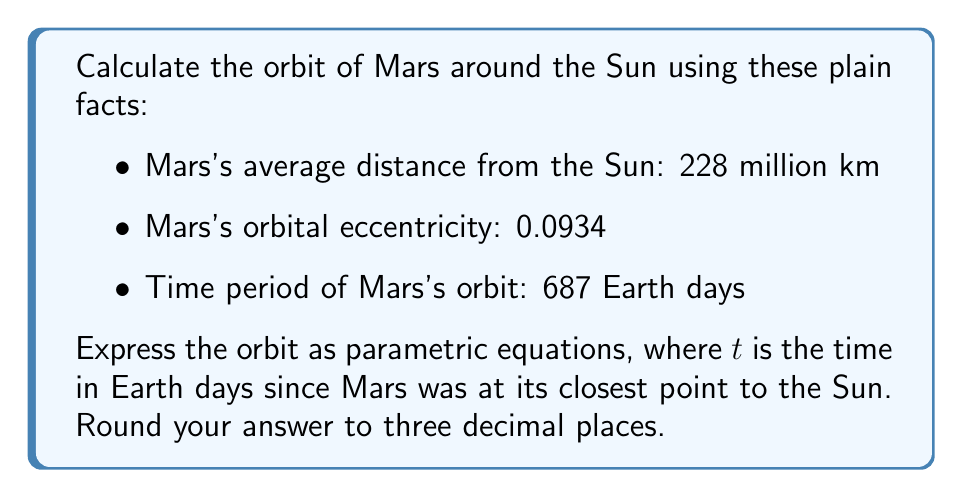Provide a solution to this math problem. Let's break this down step-by-step:

1) The orbit of a planet around the Sun is an ellipse. We can describe this using parametric equations:

   $x = a \cos(E)$
   $y = b \sin(E)$

   Where $a$ is the semi-major axis, $b$ is the semi-minor axis, and $E$ is the eccentric anomaly.

2) We're given the average distance (228 million km) which is the semi-major axis $a$.

3) The eccentricity $e$ is 0.0934. We can find $b$ using:

   $b = a\sqrt{1-e^2} = 228\sqrt{1-0.0934^2} = 226.986$ million km

4) To relate time $t$ to position, we need Kepler's equation:

   $M = E - e \sin(E)$

   Where $M$ is the mean anomaly: $M = \frac{2\pi t}{T}$, and $T$ is the orbital period (687 days).

5) We can't solve this equation directly, but we can approximate $E$ using:

   $E \approx M + e \sin(M) + \frac{e^2}{2} \sin(2M)$

6) Putting it all together:

   $M = \frac{2\pi t}{687}$
   $E \approx \frac{2\pi t}{687} + 0.0934 \sin(\frac{2\pi t}{687}) + \frac{0.0934^2}{2} \sin(\frac{4\pi t}{687})$
   $x = 228 \cos(E)$
   $y = 226.986 \sin(E)$

7) Simplifying and rounding to 3 decimal places:

   $E \approx 0.009t + 0.0934 \sin(0.009t) + 0.004 \sin(0.018t)$
   $x = 228 \cos(0.009t + 0.0934 \sin(0.009t) + 0.004 \sin(0.018t))$
   $y = 226.986 \sin(0.009t + 0.0934 \sin(0.009t) + 0.004 \sin(0.018t))$
Answer: The parametric equations for Mars's orbit, with $t$ in Earth days and distances in millions of kilometers, are:

$x = 228 \cos(0.009t + 0.0934 \sin(0.009t) + 0.004 \sin(0.018t))$
$y = 226.986 \sin(0.009t + 0.0934 \sin(0.009t) + 0.004 \sin(0.018t))$ 